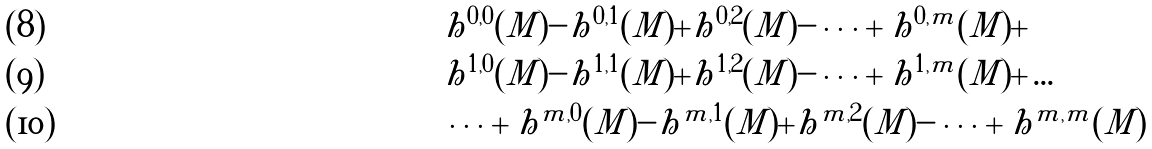<formula> <loc_0><loc_0><loc_500><loc_500>& h ^ { 0 , 0 } ( M ) - h ^ { 0 , 1 } ( M ) + h ^ { 0 , 2 } ( M ) - \cdots + h ^ { 0 , m } ( M ) + \\ & h ^ { 1 , 0 } ( M ) - h ^ { 1 , 1 } ( M ) + h ^ { 1 , 2 } ( M ) - \cdots + h ^ { 1 , m } ( M ) + \dots \\ & \dots + h ^ { m , 0 } ( M ) - h ^ { m , 1 } ( M ) + h ^ { m , 2 } ( M ) - \cdots + h ^ { m , m } ( M )</formula> 